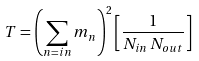<formula> <loc_0><loc_0><loc_500><loc_500>T = \left ( \sum _ { n = i n } m _ { n } \right ) ^ { 2 } \left [ \frac { 1 } { N _ { i n } \, N _ { o u t } } \right ]</formula> 